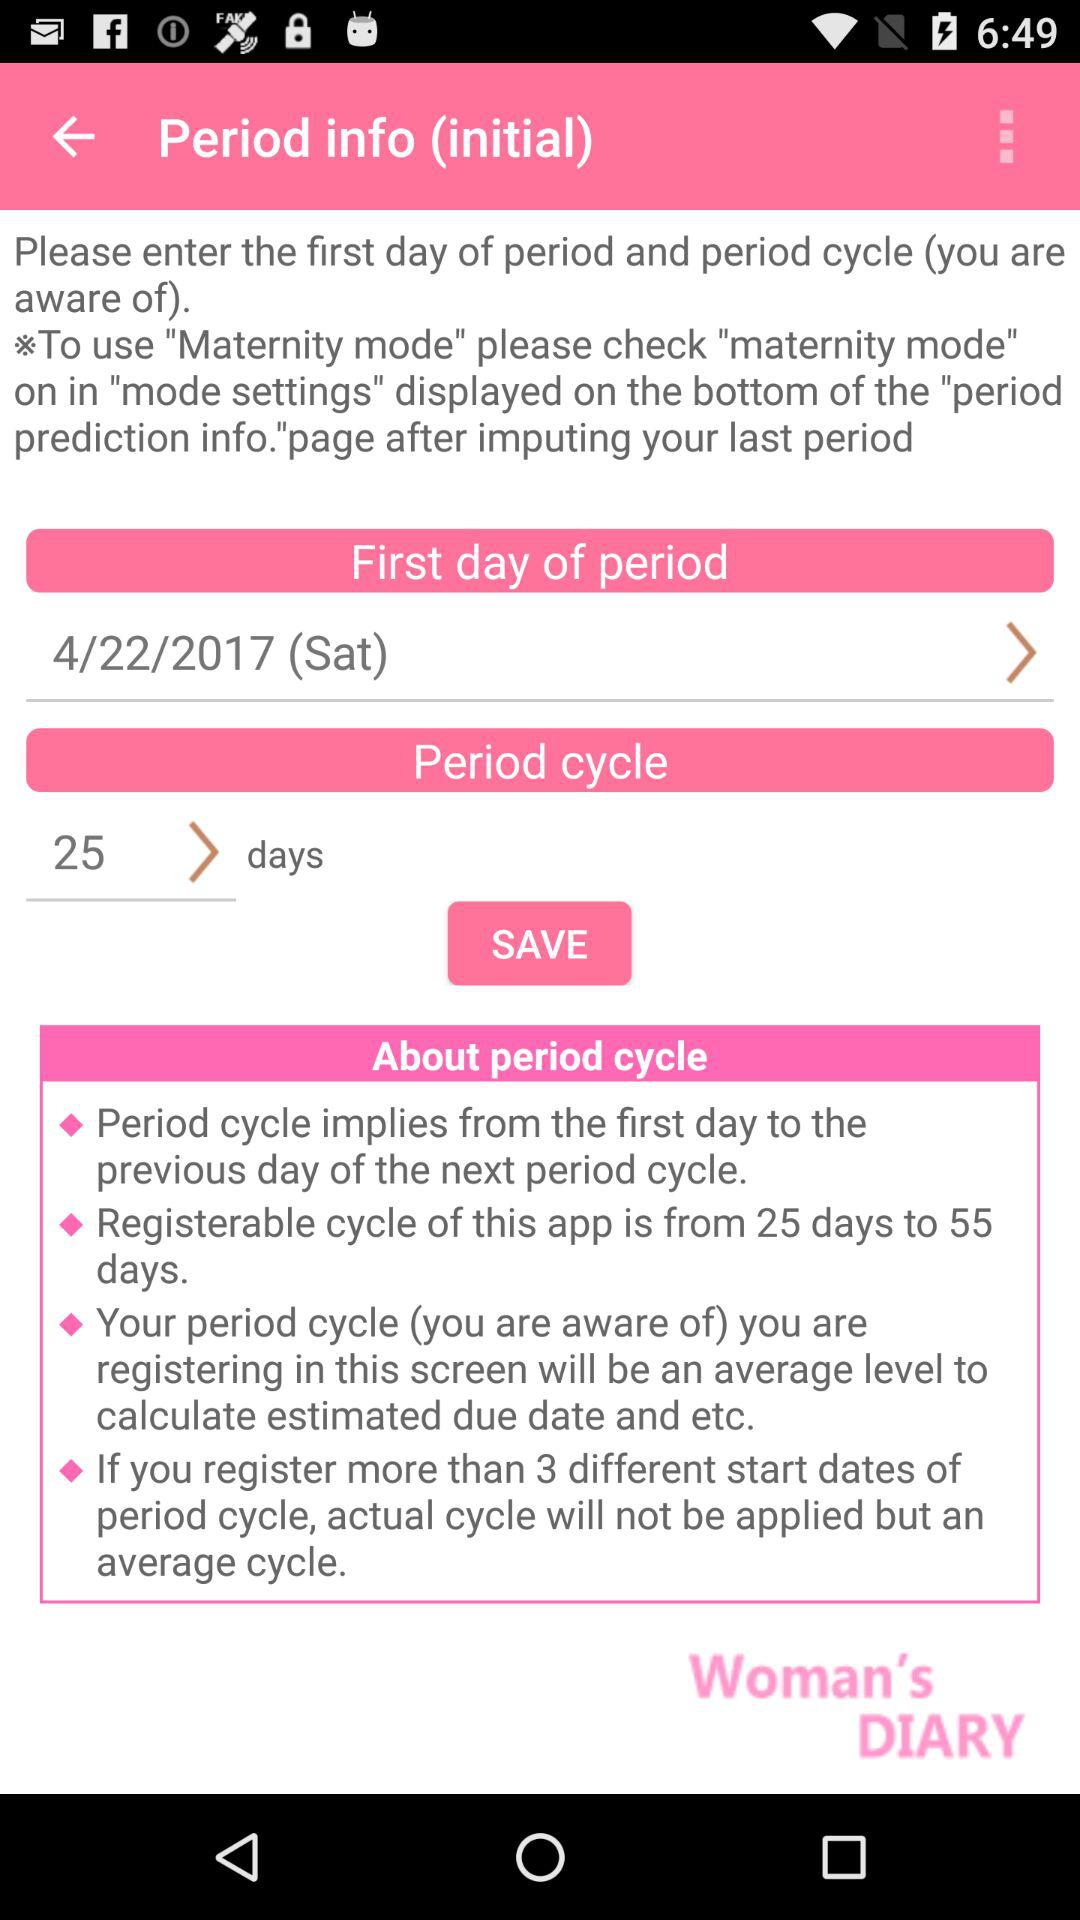How many days must a period cycle be at minimum?
Answer the question using a single word or phrase. 25 days 